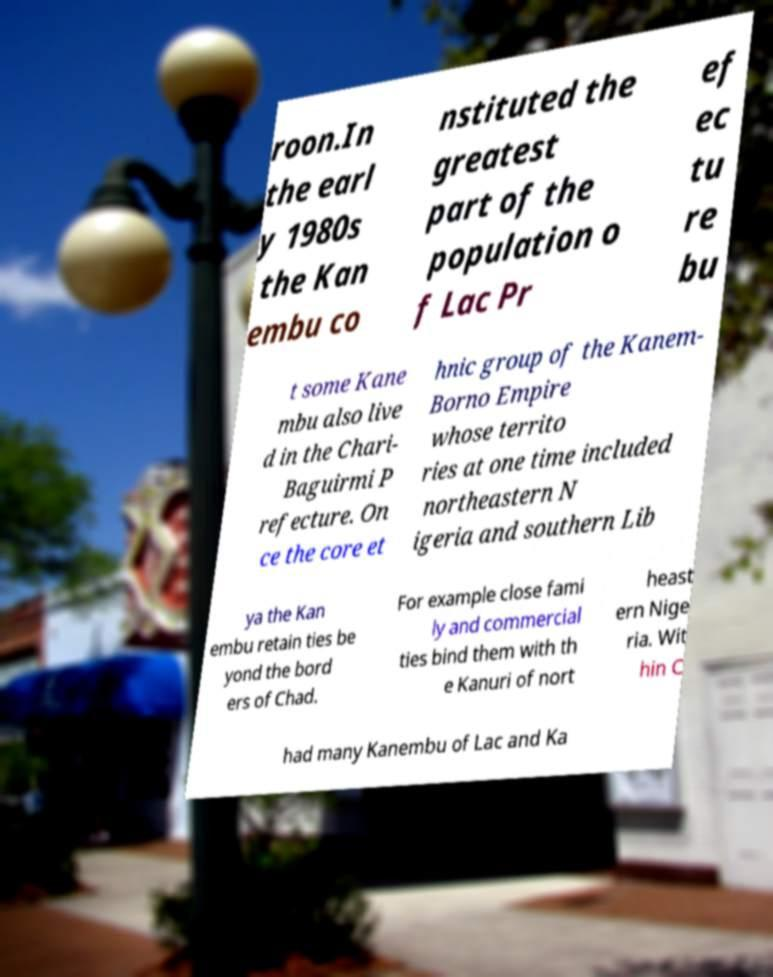Could you assist in decoding the text presented in this image and type it out clearly? roon.In the earl y 1980s the Kan embu co nstituted the greatest part of the population o f Lac Pr ef ec tu re bu t some Kane mbu also live d in the Chari- Baguirmi P refecture. On ce the core et hnic group of the Kanem- Borno Empire whose territo ries at one time included northeastern N igeria and southern Lib ya the Kan embu retain ties be yond the bord ers of Chad. For example close fami ly and commercial ties bind them with th e Kanuri of nort heast ern Nige ria. Wit hin C had many Kanembu of Lac and Ka 